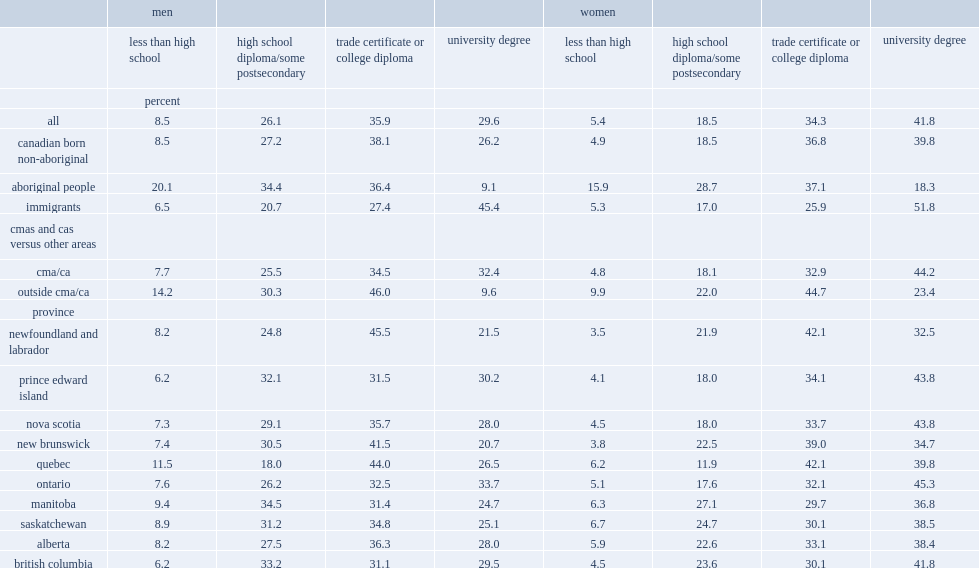Can you parse all the data within this table? {'header': ['', 'men', '', '', '', 'women', '', '', ''], 'rows': [['', 'less than high school', 'high school diploma/some postsecondary', 'trade certificate or college diploma', 'university degree', 'less than high school', 'high school diploma/some postsecondary', 'trade certificate or college diploma', 'university degree'], ['', 'percent', '', '', '', '', '', '', ''], ['all', '8.5', '26.1', '35.9', '29.6', '5.4', '18.5', '34.3', '41.8'], ['canadian born non-aboriginal', '8.5', '27.2', '38.1', '26.2', '4.9', '18.5', '36.8', '39.8'], ['aboriginal people', '20.1', '34.4', '36.4', '9.1', '15.9', '28.7', '37.1', '18.3'], ['immigrants', '6.5', '20.7', '27.4', '45.4', '5.3', '17.0', '25.9', '51.8'], ['cmas and cas versus other areas', '', '', '', '', '', '', '', ''], ['cma/ca', '7.7', '25.5', '34.5', '32.4', '4.8', '18.1', '32.9', '44.2'], ['outside cma/ca', '14.2', '30.3', '46.0', '9.6', '9.9', '22.0', '44.7', '23.4'], ['province', '', '', '', '', '', '', '', ''], ['newfoundland and labrador', '8.2', '24.8', '45.5', '21.5', '3.5', '21.9', '42.1', '32.5'], ['prince edward island', '6.2', '32.1', '31.5', '30.2', '4.1', '18.0', '34.1', '43.8'], ['nova scotia', '7.3', '29.1', '35.7', '28.0', '4.5', '18.0', '33.7', '43.8'], ['new brunswick', '7.4', '30.5', '41.5', '20.7', '3.8', '22.5', '39.0', '34.7'], ['quebec', '11.5', '18.0', '44.0', '26.5', '6.2', '11.9', '42.1', '39.8'], ['ontario', '7.6', '26.2', '32.5', '33.7', '5.1', '17.6', '32.1', '45.3'], ['manitoba', '9.4', '34.5', '31.4', '24.7', '6.3', '27.1', '29.7', '36.8'], ['saskatchewan', '8.9', '31.2', '34.8', '25.1', '6.7', '24.7', '30.1', '38.5'], ['alberta', '8.2', '27.5', '36.3', '28.0', '5.9', '22.6', '33.1', '38.4'], ['british columbia', '6.2', '33.2', '31.1', '29.5', '4.5', '23.6', '30.1', '41.8']]} What percent of men aged 25 to 34 across educational categories had less than a high school diploma in 2016? 8.5. What percent of men aged 25 to 34 across educational categories had a high school diploma or some postsecondary education? 26.1. What percent of men aged 25 to 34 across educational categories had a trade certificate or college diploma? 35.9. What percent of men aged 25 to 34 across educational categories had a university degree? 29.6. Which sector of people, regardless of male or female, were more likely to have less than a high school diploma? Aboriginal people. What percent of aboriginal men did not have a high school diploma? 20.1. What percent of aboriginal women did not have a high school diploma? 15.9. What are the percentages of people did not have a high school diploma among immigrants, for men and women respectively? 6.5 5.3. What are the percentages of people did not have a high school diploma among canadian born non-aboriginal, for men and women respectively? 8.5 4.9. Among men, which province had the highest proportion of individuals without a high school diploma? Quebec. Which province had the lowest proportions of individuals without a high school diploma among men aged 25 to 34? Prince edward island british columbia. 